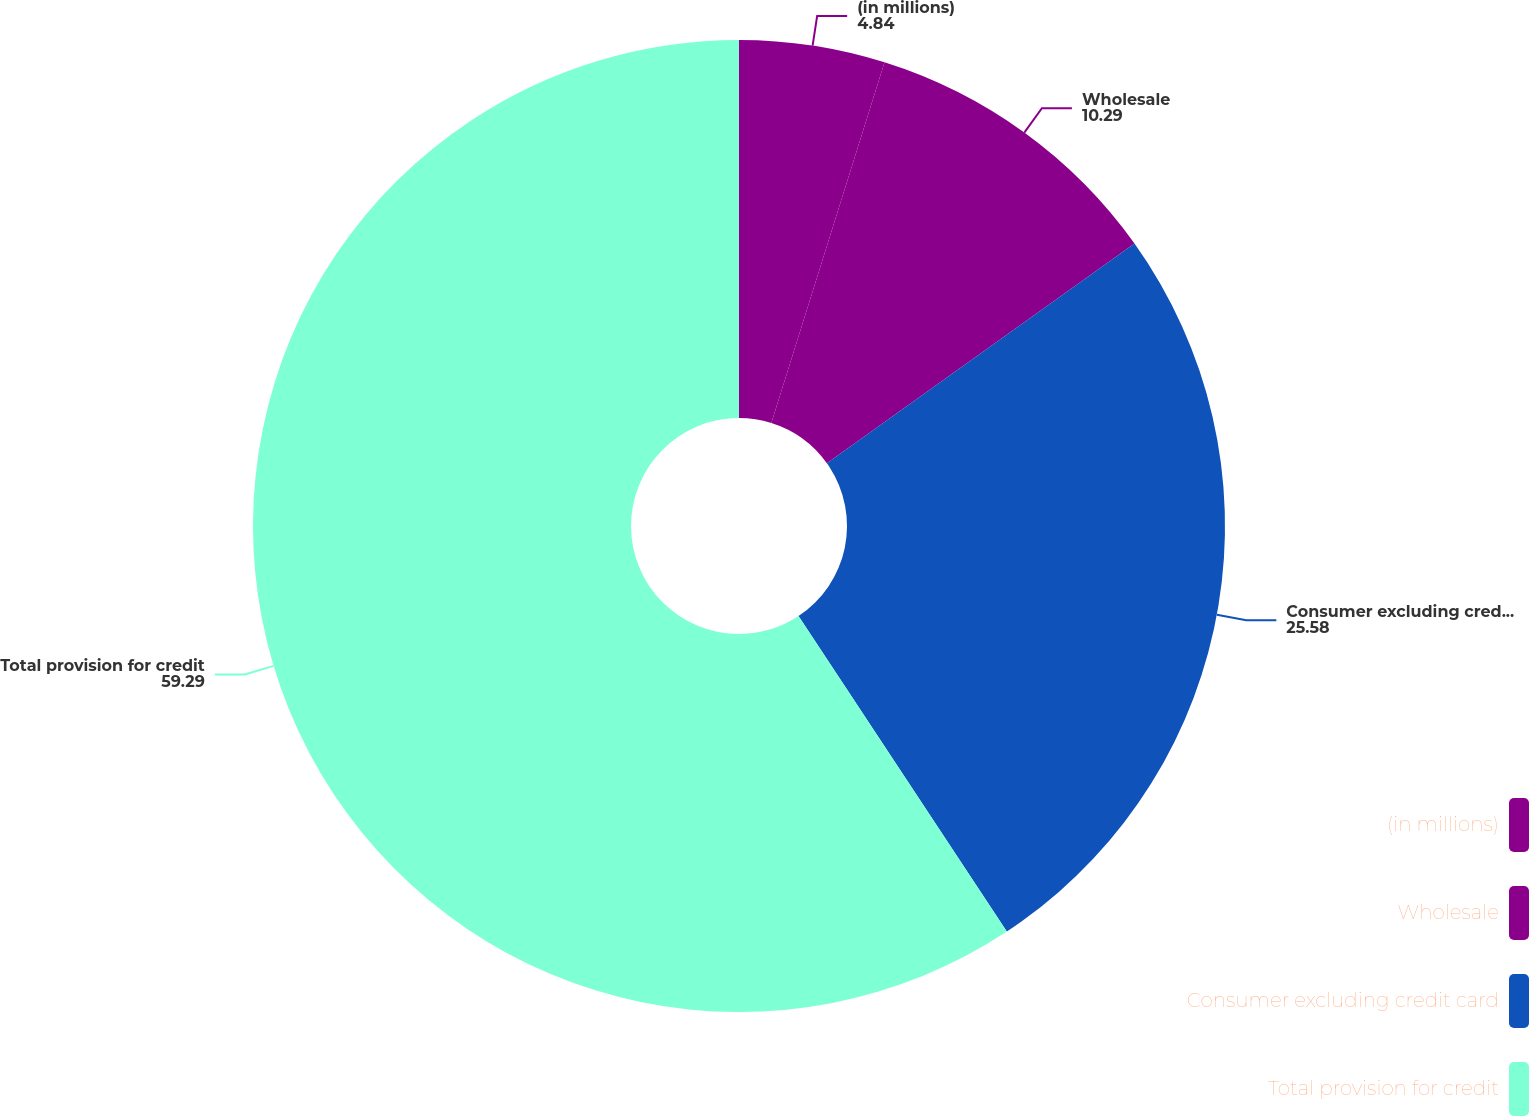Convert chart to OTSL. <chart><loc_0><loc_0><loc_500><loc_500><pie_chart><fcel>(in millions)<fcel>Wholesale<fcel>Consumer excluding credit card<fcel>Total provision for credit<nl><fcel>4.84%<fcel>10.29%<fcel>25.58%<fcel>59.29%<nl></chart> 